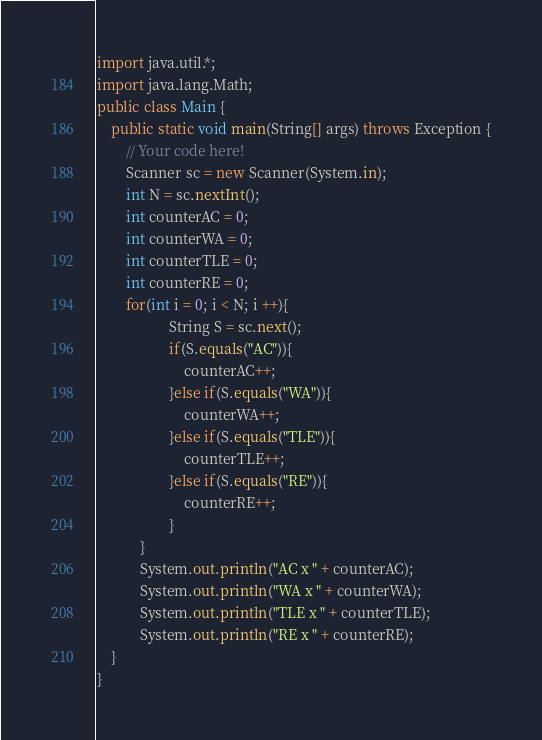<code> <loc_0><loc_0><loc_500><loc_500><_Java_>import java.util.*;
import java.lang.Math;
public class Main {
    public static void main(String[] args) throws Exception {
        // Your code here!
        Scanner sc = new Scanner(System.in);
        int N = sc.nextInt();
        int counterAC = 0;
        int counterWA = 0;
        int counterTLE = 0;
        int counterRE = 0;
        for(int i = 0; i < N; i ++){
                    String S = sc.next();
                    if(S.equals("AC")){
                        counterAC++;
                    }else if(S.equals("WA")){
                        counterWA++;
                    }else if(S.equals("TLE")){
                        counterTLE++;
                    }else if(S.equals("RE")){
                        counterRE++;
                    }
            }
            System.out.println("AC x " + counterAC);
            System.out.println("WA x " + counterWA);
            System.out.println("TLE x " + counterTLE);
            System.out.println("RE x " + counterRE);
    }
}
</code> 